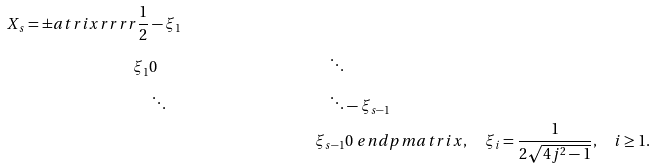Convert formula to latex. <formula><loc_0><loc_0><loc_500><loc_500>X _ { s } = \pm a t r i x { r r r r } \frac { 1 } 2 & - \xi _ { 1 } \\ \xi _ { 1 } & 0 & \ddots \\ & \ddots & \ddots & - \xi _ { s - 1 } \\ & & \xi _ { s - 1 } & 0 \ e n d p m a t r i x , \quad \xi _ { i } = \frac { 1 } { 2 \sqrt { 4 j ^ { 2 } - 1 } } , \quad i \geq 1 .</formula> 